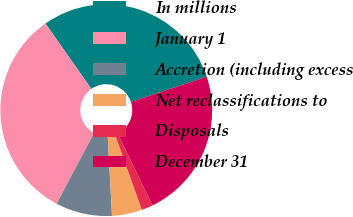Convert chart to OTSL. <chart><loc_0><loc_0><loc_500><loc_500><pie_chart><fcel>In millions<fcel>January 1<fcel>Accretion (including excess<fcel>Net reclassifications to<fcel>Disposals<fcel>December 31<nl><fcel>29.63%<fcel>32.48%<fcel>8.64%<fcel>4.59%<fcel>1.74%<fcel>22.92%<nl></chart> 